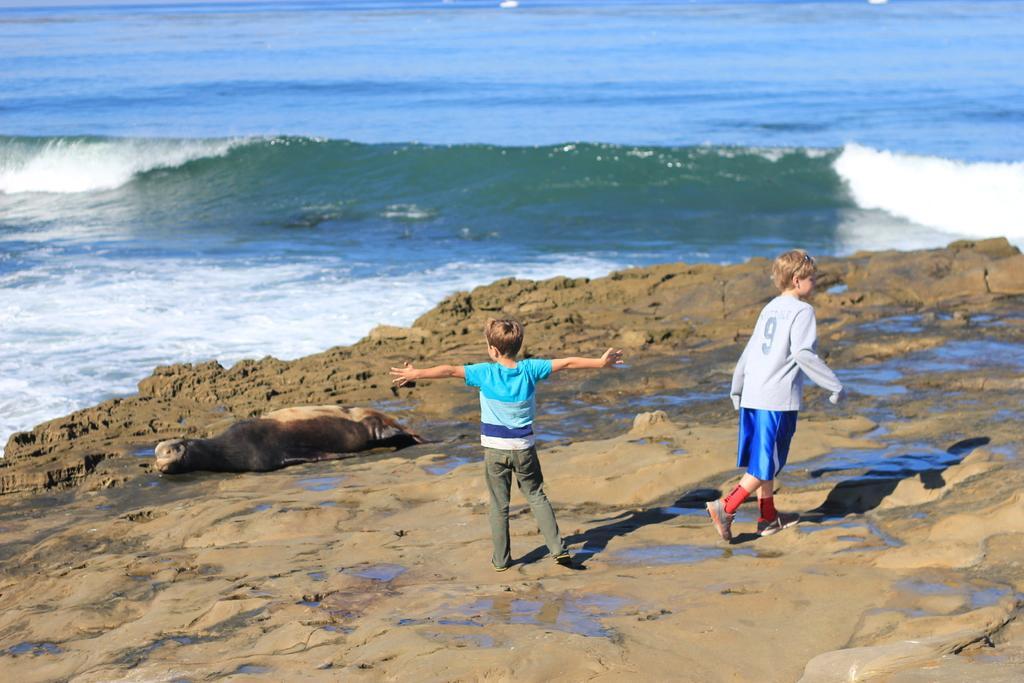Please provide a concise description of this image. On the mud surface we can see seal and two boys. Background portion of the image there is water. 